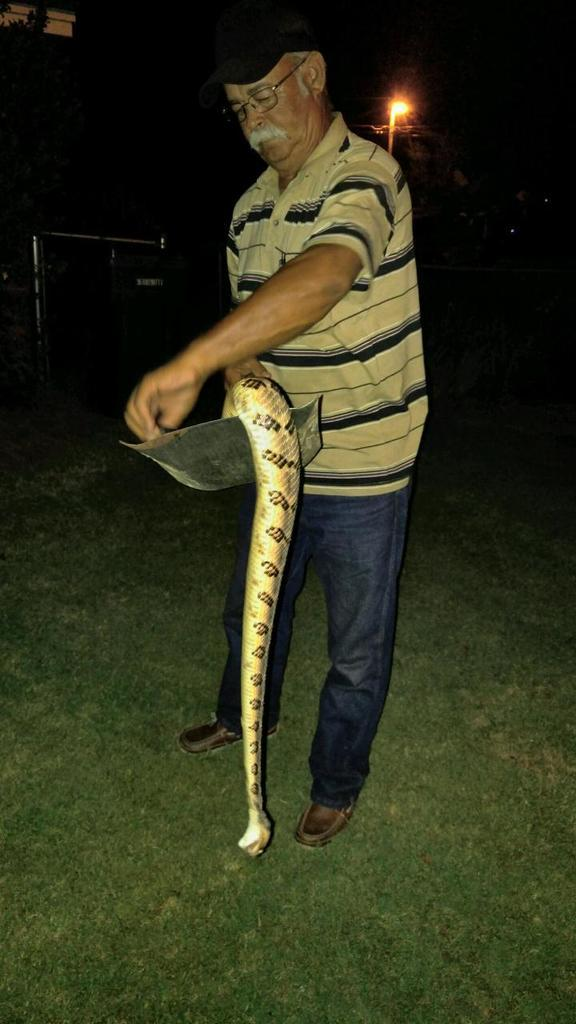What is the man in the image wearing on his face? The man is wearing glasses (specs) in the image. What type of headwear is the man wearing? The man is wearing a cap in the image. What is the man holding in the image? The man is holding a snake in a plate in the image. What is the ground surface like in the image? There is grass on the ground in the image. What can be seen in the background of the image? There is a light in the background of the image. What type of bike is the man riding in the image? There is no bike present in the image; the man is holding a snake in a plate. What is the man's selection of snacks in the image? The image does not show a selection of snacks; it only shows the man holding a snake in a plate. 